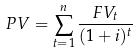<formula> <loc_0><loc_0><loc_500><loc_500>P V = \sum _ { t = 1 } ^ { n } \frac { F V _ { t } } { ( 1 + i ) ^ { t } }</formula> 